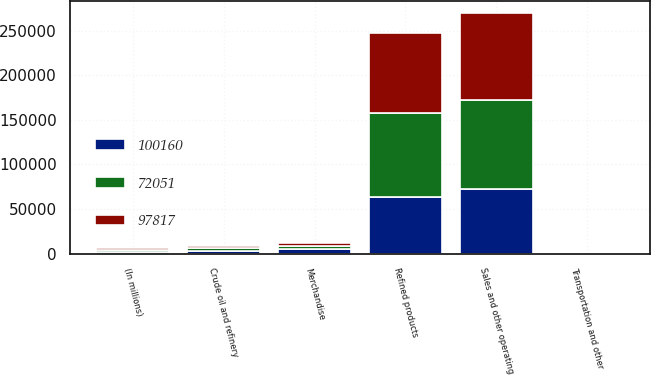Convert chart to OTSL. <chart><loc_0><loc_0><loc_500><loc_500><stacked_bar_chart><ecel><fcel>(In millions)<fcel>Refined products<fcel>Merchandise<fcel>Crude oil and refinery<fcel>Transportation and other<fcel>Sales and other operating<nl><fcel>100160<fcel>2015<fcel>63708<fcel>5188<fcel>2718<fcel>437<fcel>72051<nl><fcel>97817<fcel>2014<fcel>90702<fcel>3817<fcel>2917<fcel>381<fcel>97817<nl><fcel>72051<fcel>2013<fcel>93520<fcel>3308<fcel>2988<fcel>344<fcel>100160<nl></chart> 